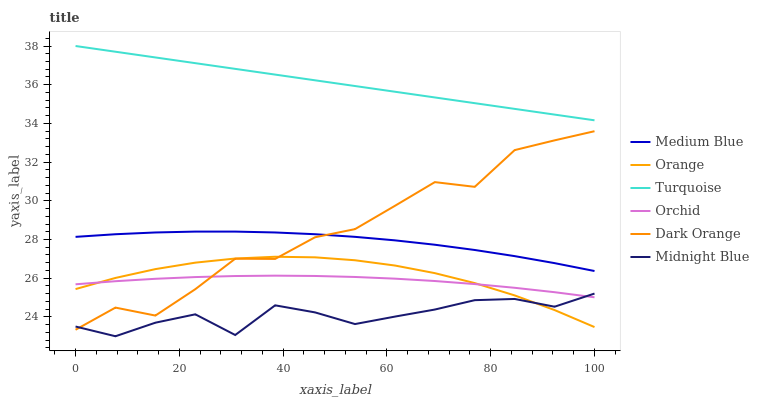Does Midnight Blue have the minimum area under the curve?
Answer yes or no. Yes. Does Turquoise have the maximum area under the curve?
Answer yes or no. Yes. Does Turquoise have the minimum area under the curve?
Answer yes or no. No. Does Midnight Blue have the maximum area under the curve?
Answer yes or no. No. Is Turquoise the smoothest?
Answer yes or no. Yes. Is Dark Orange the roughest?
Answer yes or no. Yes. Is Midnight Blue the smoothest?
Answer yes or no. No. Is Midnight Blue the roughest?
Answer yes or no. No. Does Midnight Blue have the lowest value?
Answer yes or no. Yes. Does Turquoise have the lowest value?
Answer yes or no. No. Does Turquoise have the highest value?
Answer yes or no. Yes. Does Midnight Blue have the highest value?
Answer yes or no. No. Is Midnight Blue less than Medium Blue?
Answer yes or no. Yes. Is Turquoise greater than Orchid?
Answer yes or no. Yes. Does Medium Blue intersect Dark Orange?
Answer yes or no. Yes. Is Medium Blue less than Dark Orange?
Answer yes or no. No. Is Medium Blue greater than Dark Orange?
Answer yes or no. No. Does Midnight Blue intersect Medium Blue?
Answer yes or no. No. 